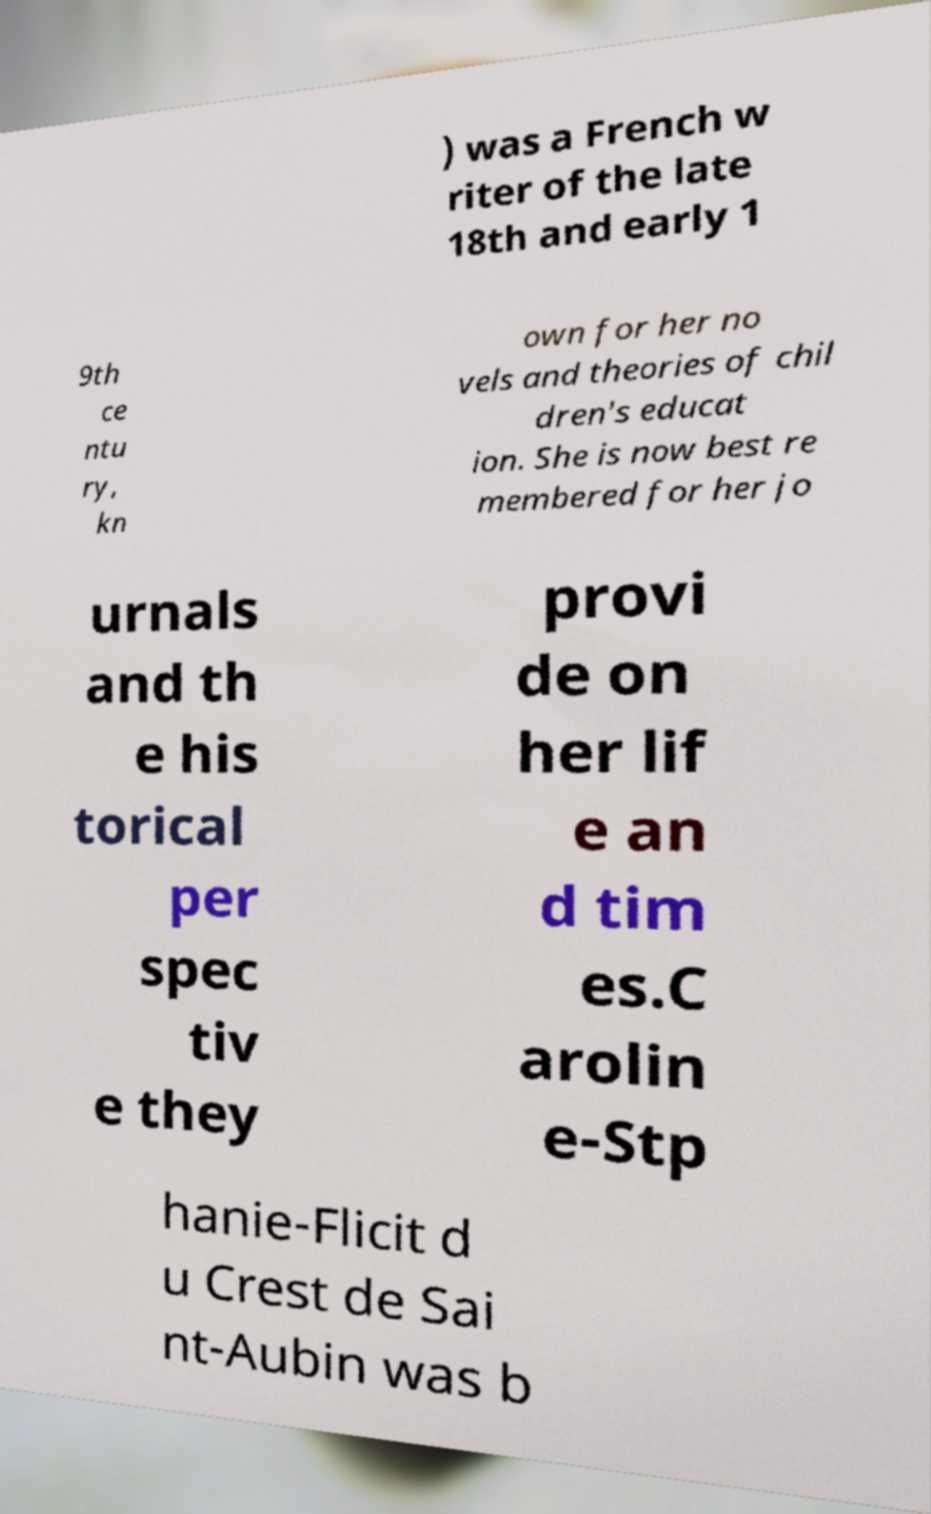Please read and relay the text visible in this image. What does it say? ) was a French w riter of the late 18th and early 1 9th ce ntu ry, kn own for her no vels and theories of chil dren's educat ion. She is now best re membered for her jo urnals and th e his torical per spec tiv e they provi de on her lif e an d tim es.C arolin e-Stp hanie-Flicit d u Crest de Sai nt-Aubin was b 